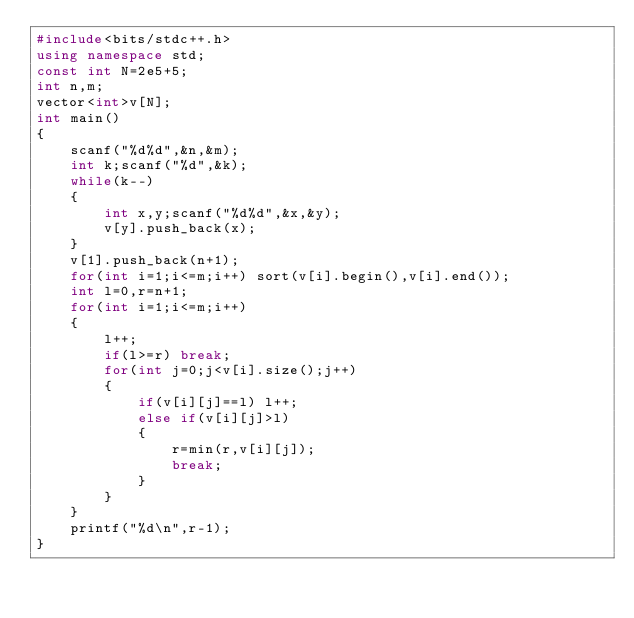<code> <loc_0><loc_0><loc_500><loc_500><_C++_>#include<bits/stdc++.h>
using namespace std;
const int N=2e5+5;
int n,m;
vector<int>v[N];
int main()
{
    scanf("%d%d",&n,&m);
    int k;scanf("%d",&k);
    while(k--)
    {
        int x,y;scanf("%d%d",&x,&y);
        v[y].push_back(x);
    }
    v[1].push_back(n+1);
    for(int i=1;i<=m;i++) sort(v[i].begin(),v[i].end());
    int l=0,r=n+1;
    for(int i=1;i<=m;i++)
    {
        l++;
        if(l>=r) break;
        for(int j=0;j<v[i].size();j++)
        {
            if(v[i][j]==l) l++;
            else if(v[i][j]>l)
            {
                r=min(r,v[i][j]);
                break;
            }
        }
    }
    printf("%d\n",r-1);
}
</code> 